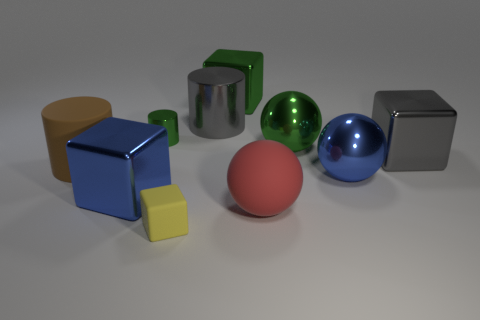What can you tell me about the colors and shapes present in this image? The image presents a vibrant mix of colors and shapes. We see geometric forms such as cubes, a cylinder, and spheres. The colors include blue, red, green, orange, and silver. Each object's color is distinct, making the shapes easily distinguishable. The blue objects include a large cube and a sphere, while red is represented by a matte cube, and green appears in both a shiny sphere and a matte cylinder. The silver color is seen on a metallic cube and cylindrical object, whereas orange is featured on a large cylinder. 